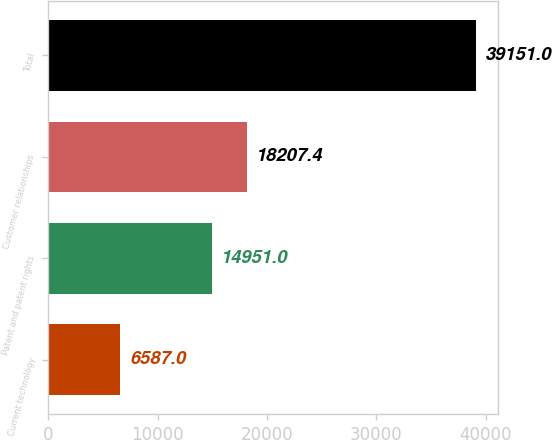<chart> <loc_0><loc_0><loc_500><loc_500><bar_chart><fcel>Current technology<fcel>Patent and patent rights<fcel>Customer relationships<fcel>Total<nl><fcel>6587<fcel>14951<fcel>18207.4<fcel>39151<nl></chart> 